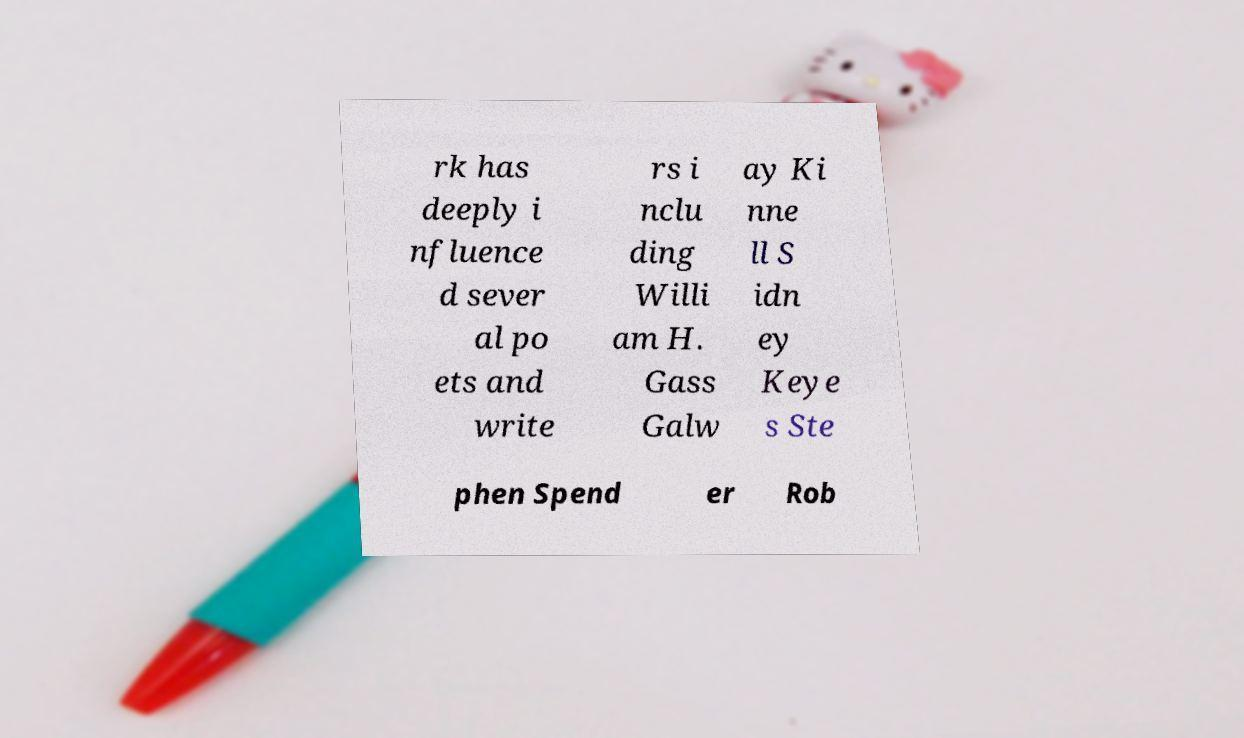What messages or text are displayed in this image? I need them in a readable, typed format. rk has deeply i nfluence d sever al po ets and write rs i nclu ding Willi am H. Gass Galw ay Ki nne ll S idn ey Keye s Ste phen Spend er Rob 